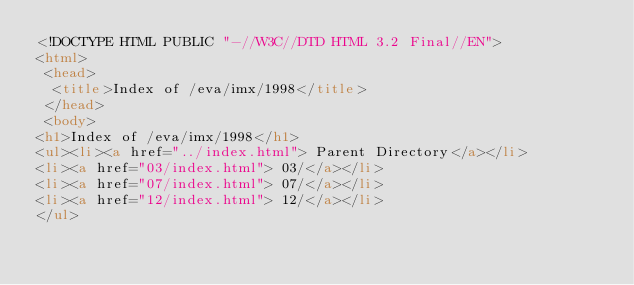Convert code to text. <code><loc_0><loc_0><loc_500><loc_500><_HTML_><!DOCTYPE HTML PUBLIC "-//W3C//DTD HTML 3.2 Final//EN">
<html>
 <head>
  <title>Index of /eva/imx/1998</title>
 </head>
 <body>
<h1>Index of /eva/imx/1998</h1>
<ul><li><a href="../index.html"> Parent Directory</a></li>
<li><a href="03/index.html"> 03/</a></li>
<li><a href="07/index.html"> 07/</a></li>
<li><a href="12/index.html"> 12/</a></li>
</ul></code> 